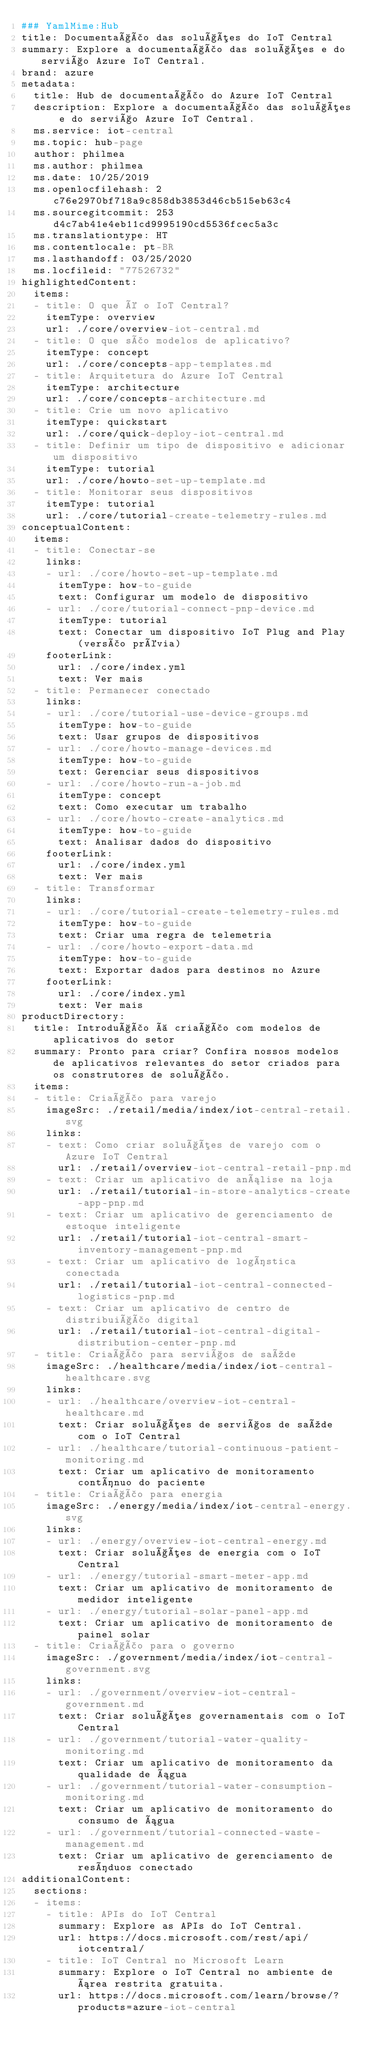Convert code to text. <code><loc_0><loc_0><loc_500><loc_500><_YAML_>### YamlMime:Hub
title: Documentação das soluções do IoT Central
summary: Explore a documentação das soluções e do serviço Azure IoT Central.
brand: azure
metadata:
  title: Hub de documentação do Azure IoT Central
  description: Explore a documentação das soluções e do serviço Azure IoT Central.
  ms.service: iot-central
  ms.topic: hub-page
  author: philmea
  ms.author: philmea
  ms.date: 10/25/2019
  ms.openlocfilehash: 2c76e2970bf718a9c858db3853d46cb515eb63c4
  ms.sourcegitcommit: 253d4c7ab41e4eb11cd9995190cd5536fcec5a3c
  ms.translationtype: HT
  ms.contentlocale: pt-BR
  ms.lasthandoff: 03/25/2020
  ms.locfileid: "77526732"
highlightedContent:
  items:
  - title: O que é o IoT Central?
    itemType: overview
    url: ./core/overview-iot-central.md
  - title: O que são modelos de aplicativo?
    itemType: concept
    url: ./core/concepts-app-templates.md
  - title: Arquitetura do Azure IoT Central
    itemType: architecture
    url: ./core/concepts-architecture.md
  - title: Crie um novo aplicativo
    itemType: quickstart
    url: ./core/quick-deploy-iot-central.md
  - title: Definir um tipo de dispositivo e adicionar um dispositivo
    itemType: tutorial
    url: ./core/howto-set-up-template.md
  - title: Monitorar seus dispositivos
    itemType: tutorial
    url: ./core/tutorial-create-telemetry-rules.md
conceptualContent:
  items:
  - title: Conectar-se
    links:
    - url: ./core/howto-set-up-template.md
      itemType: how-to-guide
      text: Configurar um modelo de dispositivo
    - url: ./core/tutorial-connect-pnp-device.md
      itemType: tutorial
      text: Conectar um dispositivo IoT Plug and Play (versão prévia)
    footerLink:
      url: ./core/index.yml
      text: Ver mais
  - title: Permanecer conectado
    links:
    - url: ./core/tutorial-use-device-groups.md
      itemType: how-to-guide
      text: Usar grupos de dispositivos
    - url: ./core/howto-manage-devices.md
      itemType: how-to-guide
      text: Gerenciar seus dispositivos
    - url: ./core/howto-run-a-job.md
      itemType: concept
      text: Como executar um trabalho
    - url: ./core/howto-create-analytics.md
      itemType: how-to-guide
      text: Analisar dados do dispositivo
    footerLink:
      url: ./core/index.yml
      text: Ver mais
  - title: Transformar
    links:
    - url: ./core/tutorial-create-telemetry-rules.md
      itemType: how-to-guide
      text: Criar uma regra de telemetria
    - url: ./core/howto-export-data.md
      itemType: how-to-guide
      text: Exportar dados para destinos no Azure
    footerLink:
      url: ./core/index.yml
      text: Ver mais
productDirectory:
  title: Introdução à criação com modelos de aplicativos do setor
  summary: Pronto para criar? Confira nossos modelos de aplicativos relevantes do setor criados para os construtores de solução.
  items:
  - title: Criação para varejo
    imageSrc: ./retail/media/index/iot-central-retail.svg
    links:
    - text: Como criar soluções de varejo com o Azure IoT Central
      url: ./retail/overview-iot-central-retail-pnp.md
    - text: Criar um aplicativo de análise na loja
      url: ./retail/tutorial-in-store-analytics-create-app-pnp.md
    - text: Criar um aplicativo de gerenciamento de estoque inteligente
      url: ./retail/tutorial-iot-central-smart-inventory-management-pnp.md
    - text: Criar um aplicativo de logística conectada
      url: ./retail/tutorial-iot-central-connected-logistics-pnp.md
    - text: Criar um aplicativo de centro de distribuição digital
      url: ./retail/tutorial-iot-central-digital-distribution-center-pnp.md
  - title: Criação para serviços de saúde
    imageSrc: ./healthcare/media/index/iot-central-healthcare.svg
    links:
    - url: ./healthcare/overview-iot-central-healthcare.md
      text: Criar soluções de serviços de saúde com o IoT Central
    - url: ./healthcare/tutorial-continuous-patient-monitoring.md
      text: Criar um aplicativo de monitoramento contínuo do paciente
  - title: Criação para energia
    imageSrc: ./energy/media/index/iot-central-energy.svg
    links:
    - url: ./energy/overview-iot-central-energy.md
      text: Criar soluções de energia com o IoT Central
    - url: ./energy/tutorial-smart-meter-app.md
      text: Criar um aplicativo de monitoramento de medidor inteligente
    - url: ./energy/tutorial-solar-panel-app.md
      text: Criar um aplicativo de monitoramento de painel solar
  - title: Criação para o governo
    imageSrc: ./government/media/index/iot-central-government.svg
    links:
    - url: ./government/overview-iot-central-government.md
      text: Criar soluções governamentais com o IoT Central
    - url: ./government/tutorial-water-quality-monitoring.md
      text: Criar um aplicativo de monitoramento da qualidade de água
    - url: ./government/tutorial-water-consumption-monitoring.md
      text: Criar um aplicativo de monitoramento do consumo de água
    - url: ./government/tutorial-connected-waste-management.md
      text: Criar um aplicativo de gerenciamento de resíduos conectado
additionalContent:
  sections:
  - items:
    - title: APIs do IoT Central
      summary: Explore as APIs do IoT Central.
      url: https://docs.microsoft.com/rest/api/iotcentral/
    - title: IoT Central no Microsoft Learn
      summary: Explore o IoT Central no ambiente de área restrita gratuita.
      url: https://docs.microsoft.com/learn/browse/?products=azure-iot-central
</code> 